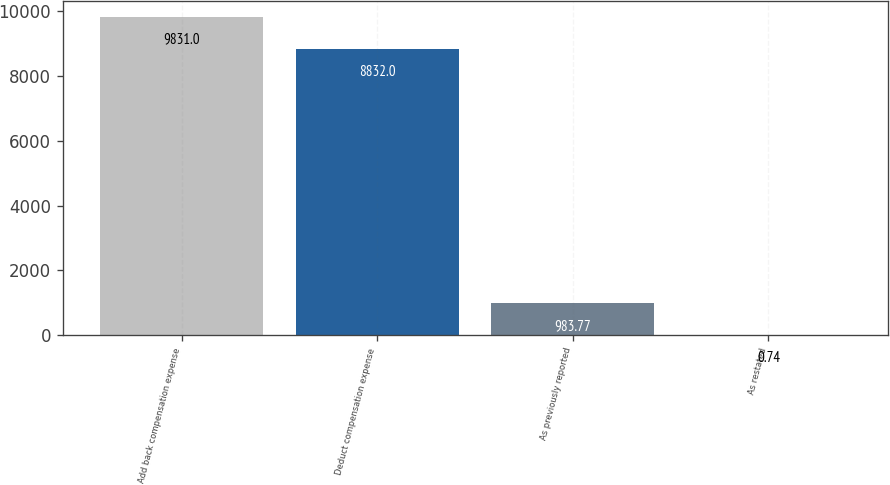Convert chart. <chart><loc_0><loc_0><loc_500><loc_500><bar_chart><fcel>Add back compensation expense<fcel>Deduct compensation expense<fcel>As previously reported<fcel>As restated<nl><fcel>9831<fcel>8832<fcel>983.77<fcel>0.74<nl></chart> 